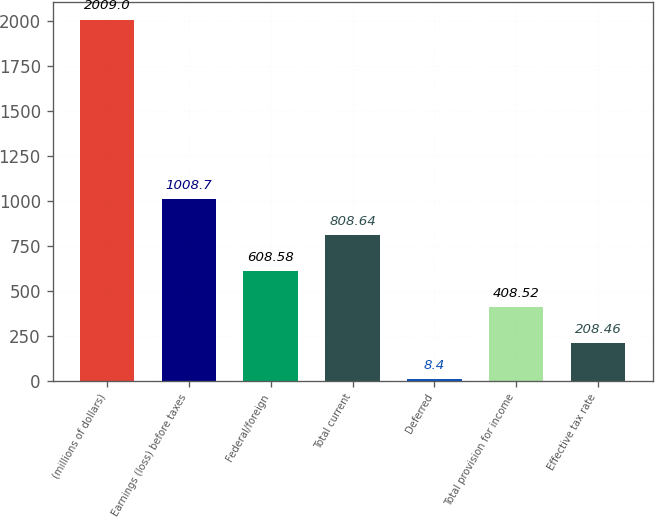Convert chart to OTSL. <chart><loc_0><loc_0><loc_500><loc_500><bar_chart><fcel>(millions of dollars)<fcel>Earnings (loss) before taxes<fcel>Federal/foreign<fcel>Total current<fcel>Deferred<fcel>Total provision for income<fcel>Effective tax rate<nl><fcel>2009<fcel>1008.7<fcel>608.58<fcel>808.64<fcel>8.4<fcel>408.52<fcel>208.46<nl></chart> 